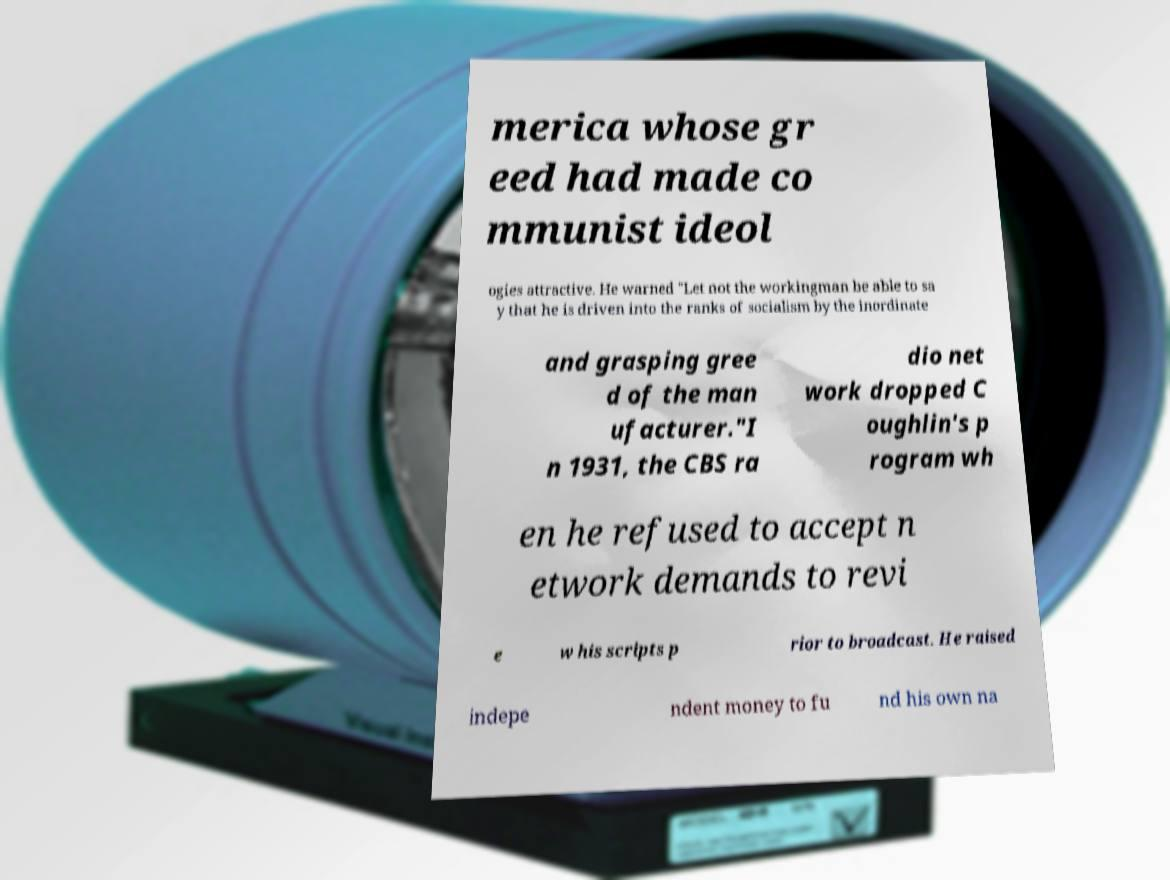I need the written content from this picture converted into text. Can you do that? merica whose gr eed had made co mmunist ideol ogies attractive. He warned "Let not the workingman be able to sa y that he is driven into the ranks of socialism by the inordinate and grasping gree d of the man ufacturer."I n 1931, the CBS ra dio net work dropped C oughlin's p rogram wh en he refused to accept n etwork demands to revi e w his scripts p rior to broadcast. He raised indepe ndent money to fu nd his own na 